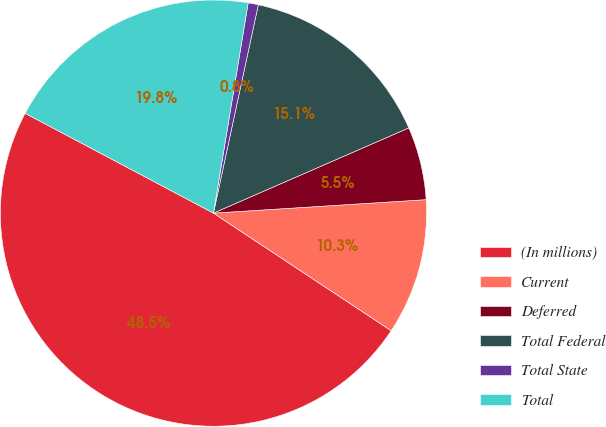<chart> <loc_0><loc_0><loc_500><loc_500><pie_chart><fcel>(In millions)<fcel>Current<fcel>Deferred<fcel>Total Federal<fcel>Total State<fcel>Total<nl><fcel>48.46%<fcel>10.31%<fcel>5.54%<fcel>15.08%<fcel>0.77%<fcel>19.85%<nl></chart> 